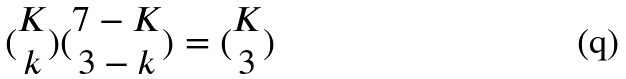<formula> <loc_0><loc_0><loc_500><loc_500>( \begin{matrix} K \\ k \end{matrix} ) ( \begin{matrix} 7 - K \\ 3 - k \end{matrix} ) = ( \begin{matrix} K \\ 3 \end{matrix} )</formula> 